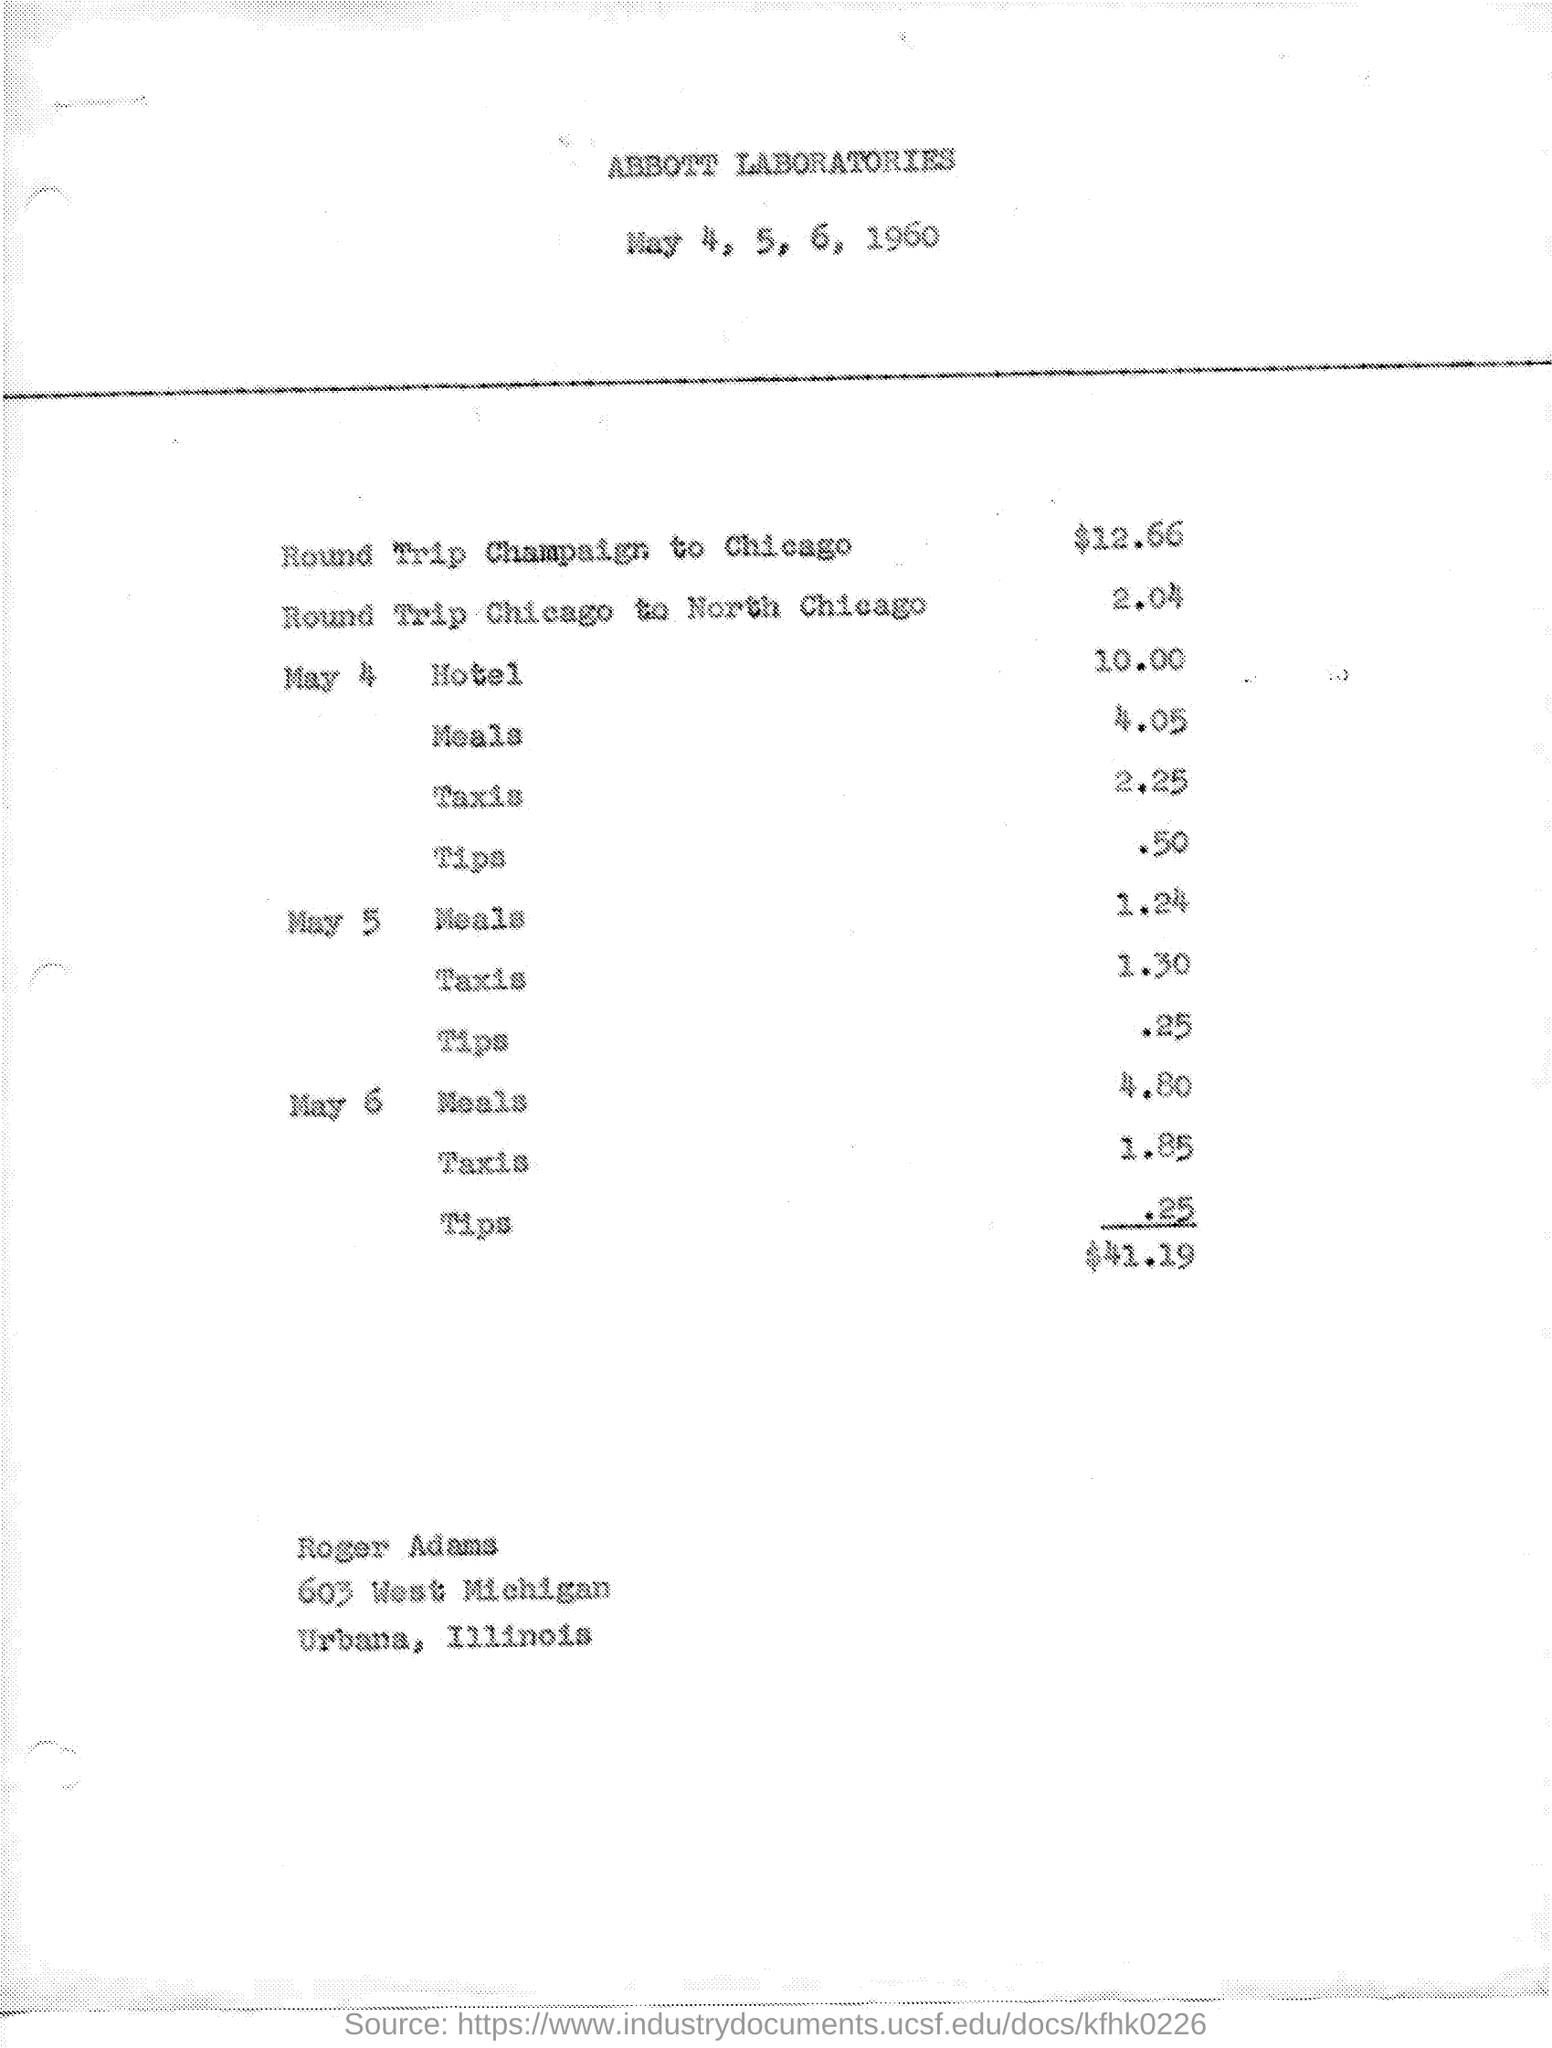Specify some key components in this picture. The total amount is $41.19. The dates mentioned are May 4, 5, 6, and 1960. The mentioned laboratory is Abbott Laboratories. 